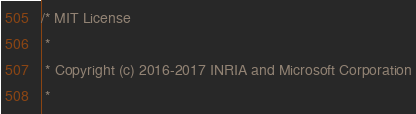Convert code to text. <code><loc_0><loc_0><loc_500><loc_500><_C_>/* MIT License
 *
 * Copyright (c) 2016-2017 INRIA and Microsoft Corporation
 *</code> 